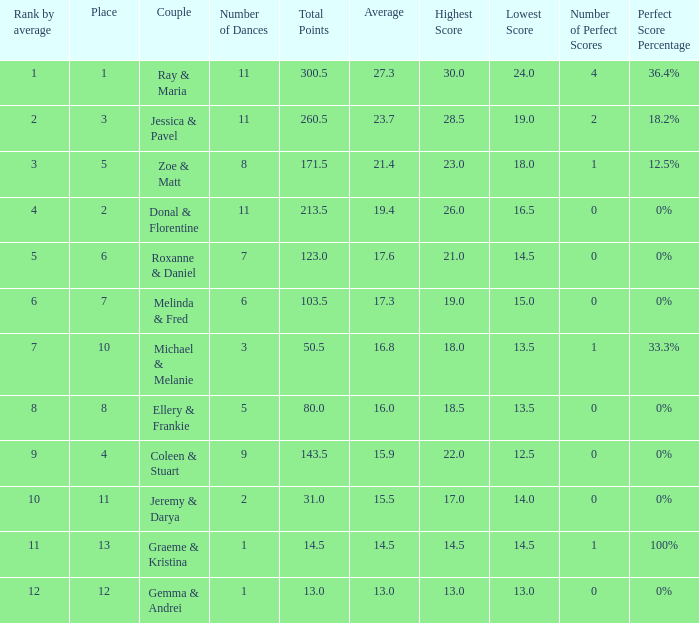What place would you be in if your rank by average is less than 2.0? 1.0. 